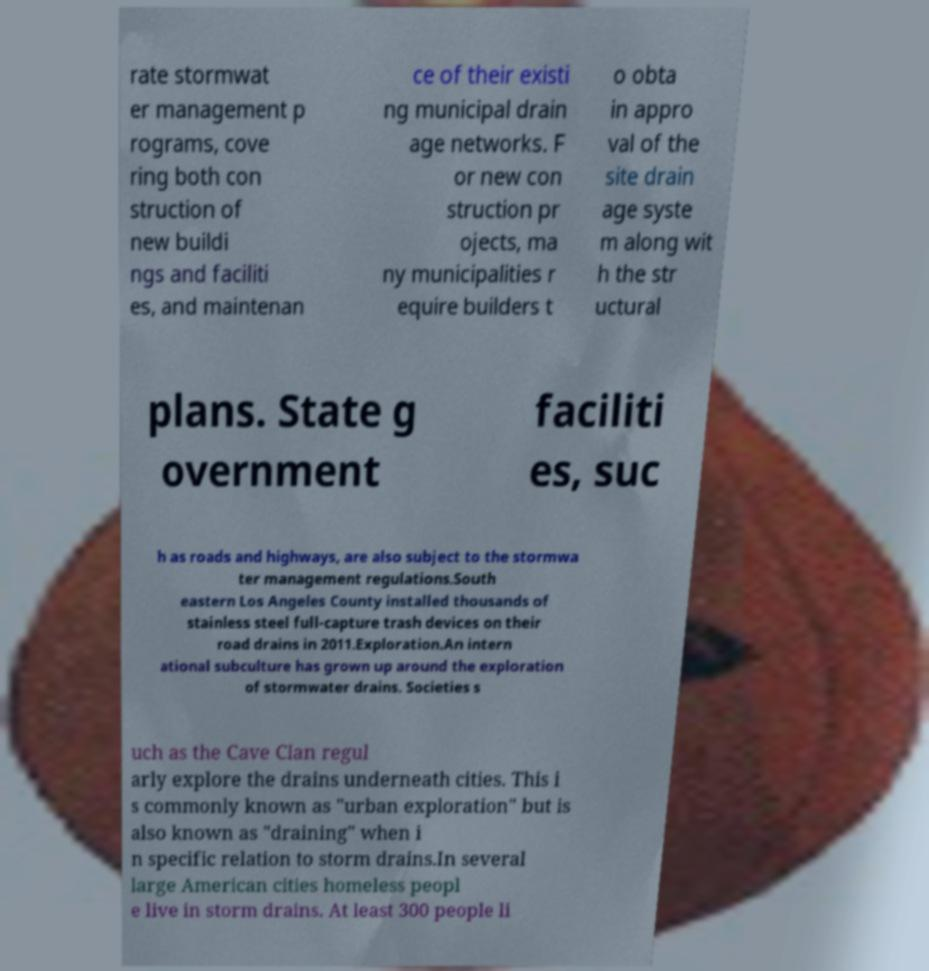I need the written content from this picture converted into text. Can you do that? rate stormwat er management p rograms, cove ring both con struction of new buildi ngs and faciliti es, and maintenan ce of their existi ng municipal drain age networks. F or new con struction pr ojects, ma ny municipalities r equire builders t o obta in appro val of the site drain age syste m along wit h the str uctural plans. State g overnment faciliti es, suc h as roads and highways, are also subject to the stormwa ter management regulations.South eastern Los Angeles County installed thousands of stainless steel full-capture trash devices on their road drains in 2011.Exploration.An intern ational subculture has grown up around the exploration of stormwater drains. Societies s uch as the Cave Clan regul arly explore the drains underneath cities. This i s commonly known as "urban exploration" but is also known as "draining" when i n specific relation to storm drains.In several large American cities homeless peopl e live in storm drains. At least 300 people li 